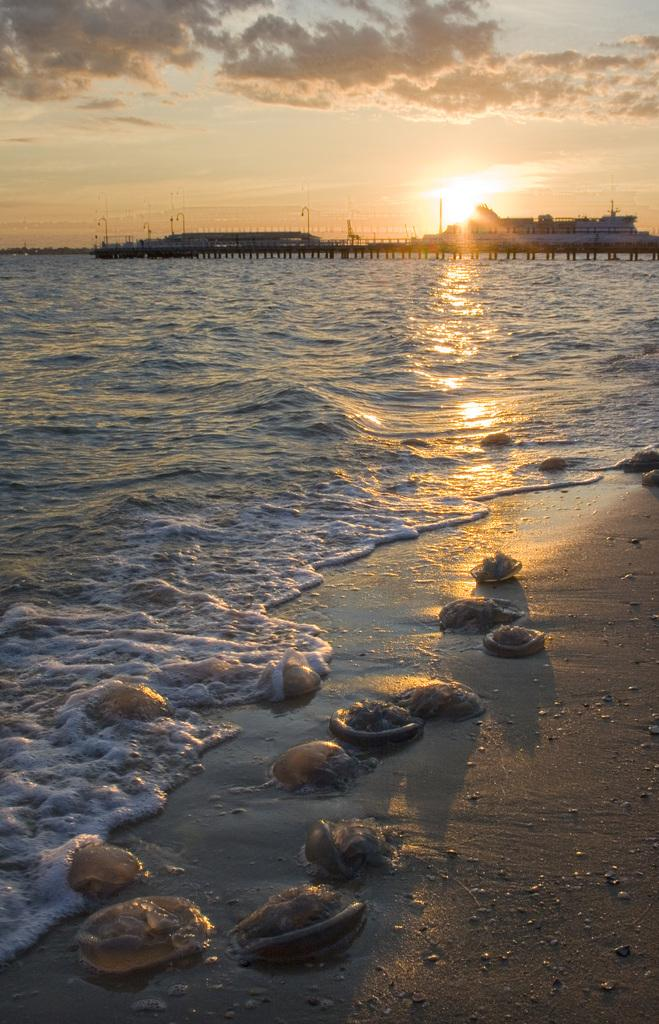What type of objects can be seen in the image? There are sea shells and ships on the water in the image. What is visible in the background of the image? Sky is visible in the background of the image. What can be seen in the sky? Clouds are present in the sky. What type of ear can be seen in the image? There is no ear present in the image. What material is the brass used for in the image? There is no brass present in the image. 